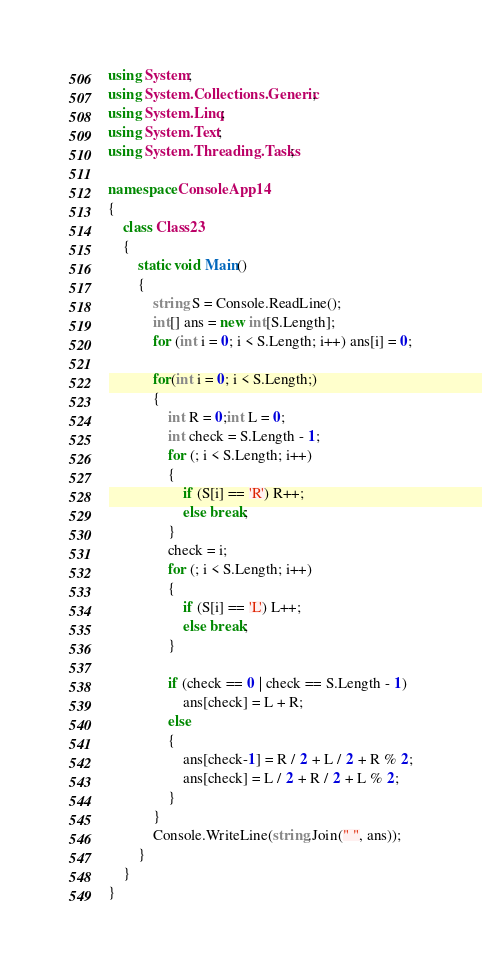Convert code to text. <code><loc_0><loc_0><loc_500><loc_500><_C#_>using System;
using System.Collections.Generic;
using System.Linq;
using System.Text;
using System.Threading.Tasks;

namespace ConsoleApp14
{
    class Class23
    {
        static void Main()
        {
            string S = Console.ReadLine();
            int[] ans = new int[S.Length];
            for (int i = 0; i < S.Length; i++) ans[i] = 0;

            for(int i = 0; i < S.Length;)
            {
                int R = 0;int L = 0;
                int check = S.Length - 1;
                for (; i < S.Length; i++)
                {
                    if (S[i] == 'R') R++;
                    else break;
                }
                check = i;
                for (; i < S.Length; i++)
                {
                    if (S[i] == 'L') L++;
                    else break;
                }

                if (check == 0 | check == S.Length - 1)
                    ans[check] = L + R;
                else
                {
                    ans[check-1] = R / 2 + L / 2 + R % 2;
                    ans[check] = L / 2 + R / 2 + L % 2;
                }
            }
            Console.WriteLine(string.Join(" ", ans));
        }
    }
}
</code> 